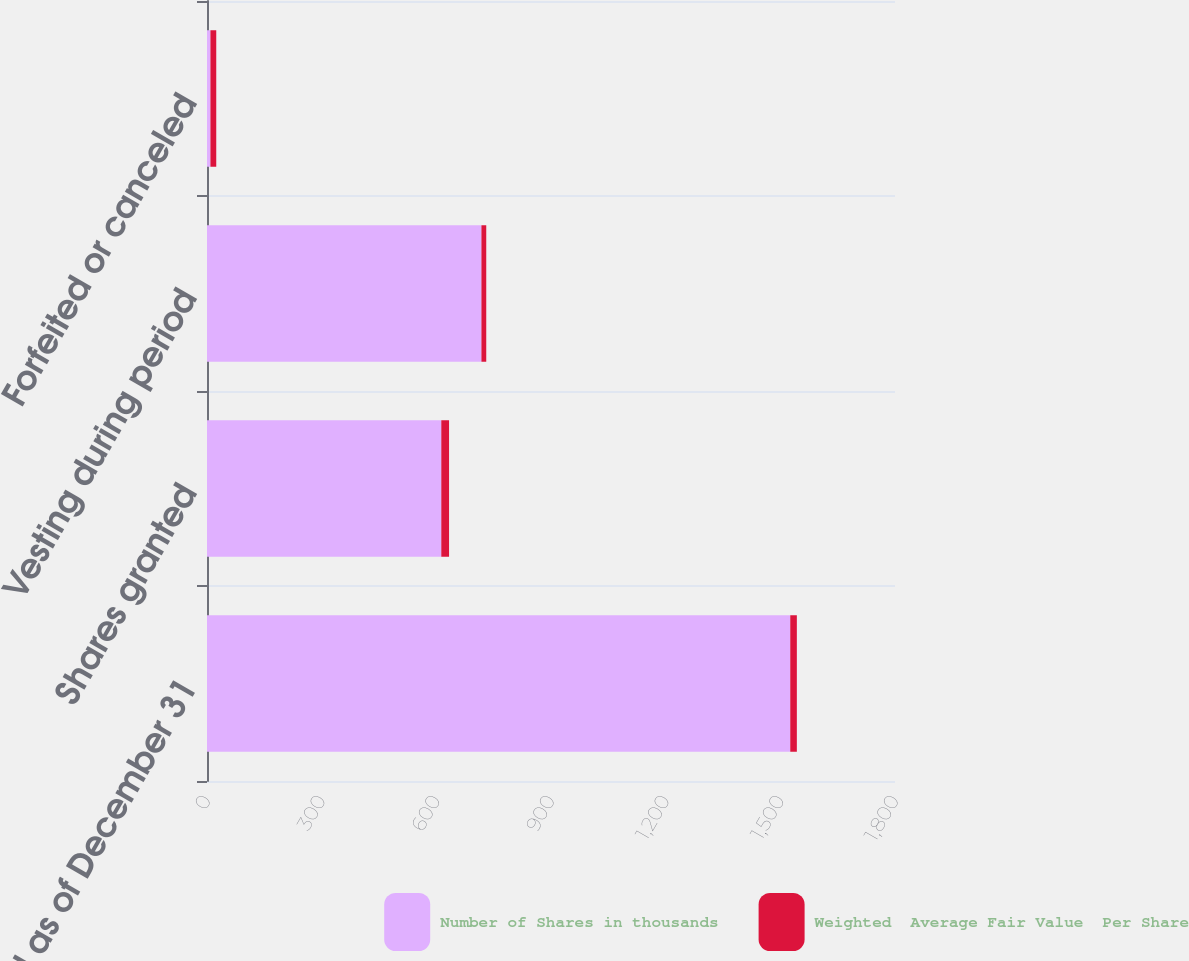Convert chart to OTSL. <chart><loc_0><loc_0><loc_500><loc_500><stacked_bar_chart><ecel><fcel>Unvested as of December 31<fcel>Shares granted<fcel>Vesting during period<fcel>Forfeited or canceled<nl><fcel>Number of Shares in thousands<fcel>1526<fcel>613<fcel>718<fcel>9<nl><fcel>Weighted  Average Fair Value  Per Share<fcel>17.2<fcel>20.31<fcel>12.58<fcel>15.2<nl></chart> 